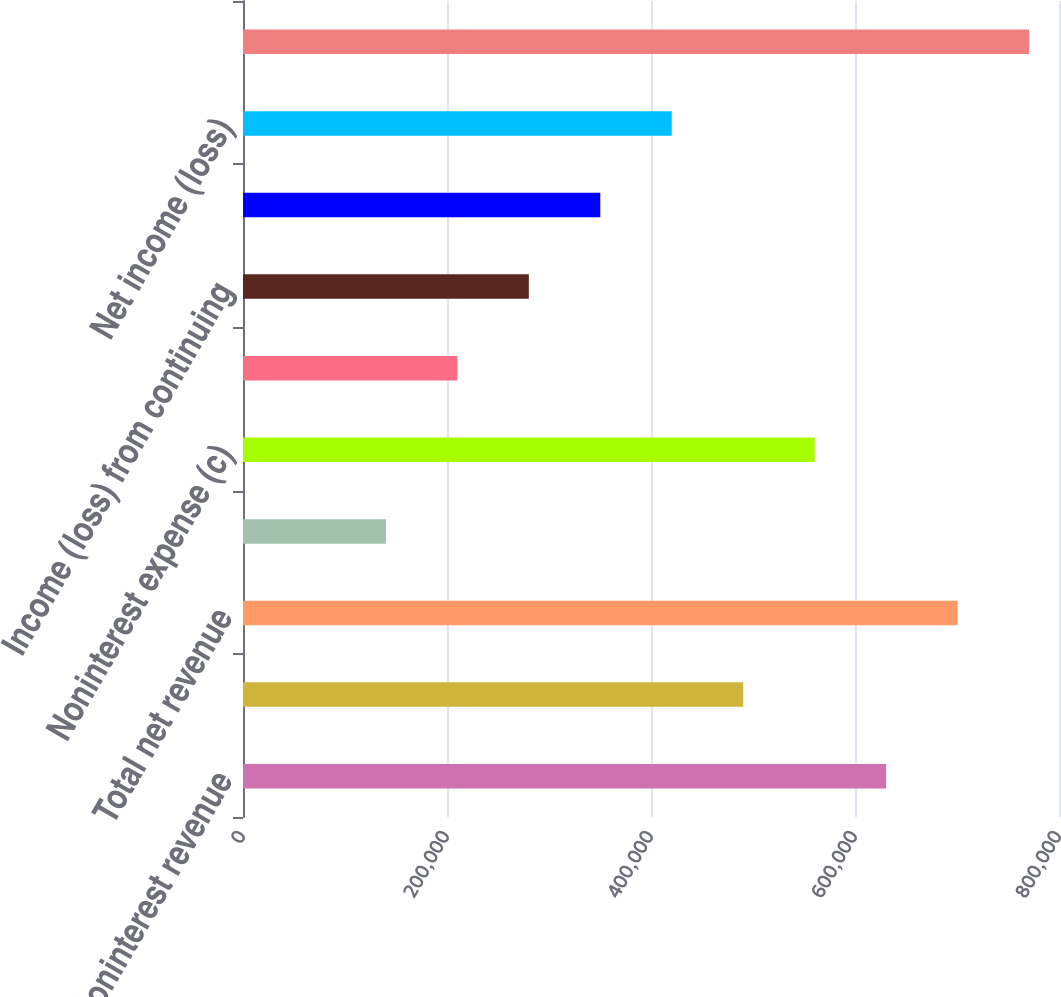Convert chart. <chart><loc_0><loc_0><loc_500><loc_500><bar_chart><fcel>Noninterest revenue<fcel>Net interest income<fcel>Total net revenue<fcel>Provision for credit losses<fcel>Noninterest expense (c)<fcel>Income tax expense (benefit)<fcel>Income (loss) from continuing<fcel>Income (loss) before<fcel>Net income (loss)<fcel>Average common equity<nl><fcel>630510<fcel>490400<fcel>700565<fcel>140125<fcel>560455<fcel>210180<fcel>280235<fcel>350290<fcel>420345<fcel>770620<nl></chart> 